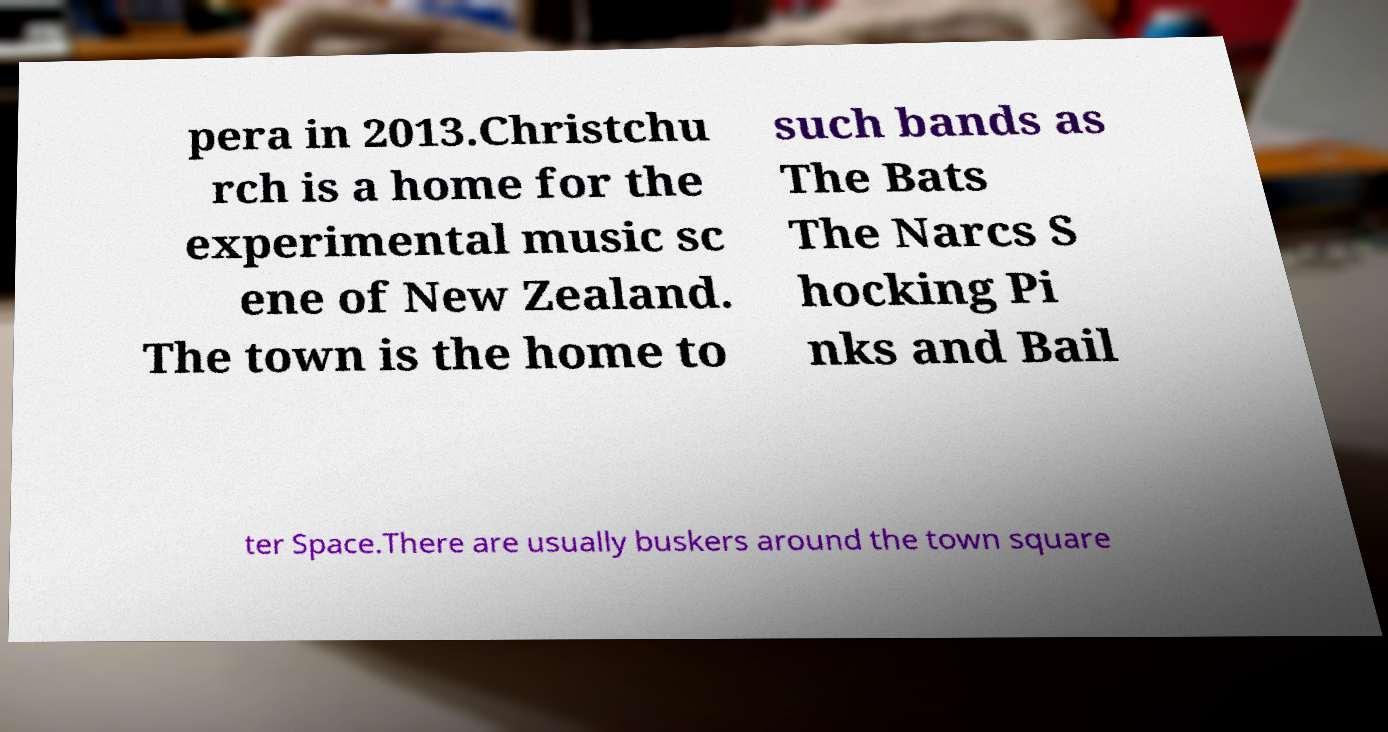Can you read and provide the text displayed in the image?This photo seems to have some interesting text. Can you extract and type it out for me? pera in 2013.Christchu rch is a home for the experimental music sc ene of New Zealand. The town is the home to such bands as The Bats The Narcs S hocking Pi nks and Bail ter Space.There are usually buskers around the town square 